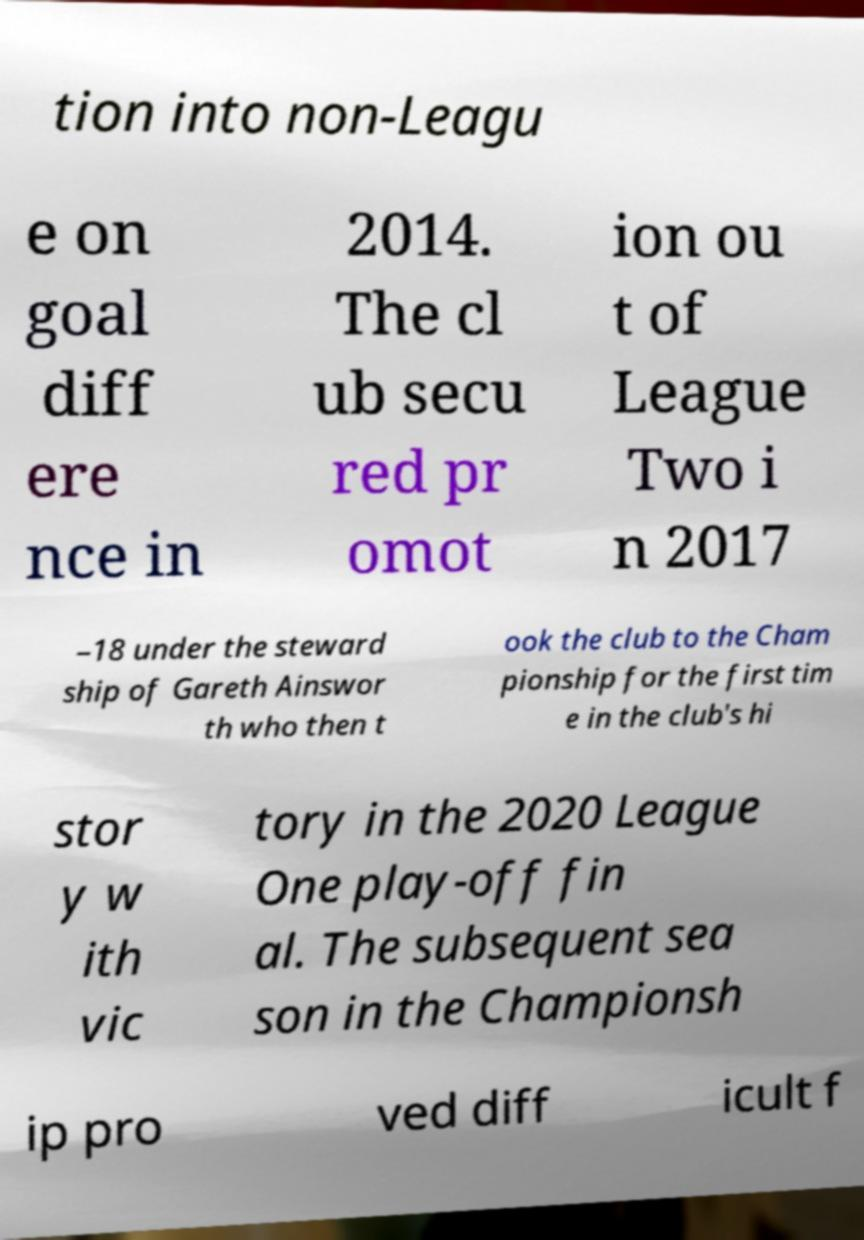There's text embedded in this image that I need extracted. Can you transcribe it verbatim? tion into non-Leagu e on goal diff ere nce in 2014. The cl ub secu red pr omot ion ou t of League Two i n 2017 –18 under the steward ship of Gareth Ainswor th who then t ook the club to the Cham pionship for the first tim e in the club's hi stor y w ith vic tory in the 2020 League One play-off fin al. The subsequent sea son in the Championsh ip pro ved diff icult f 